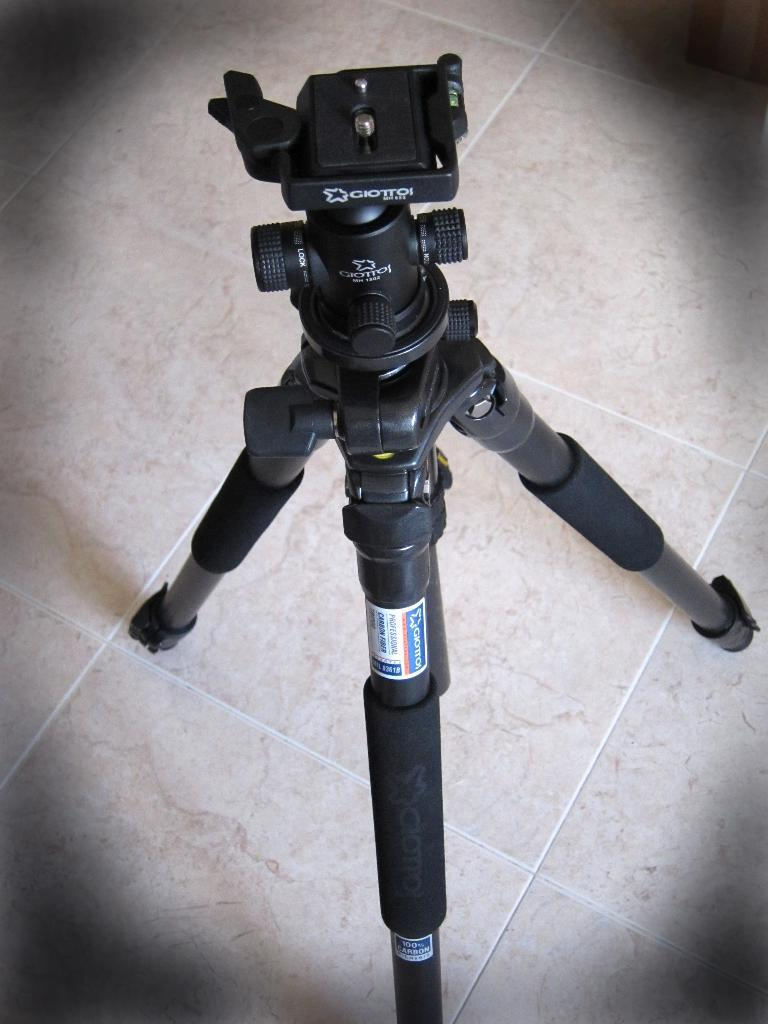What is the main object in the image? There is a camera tripod stand in the image. What type of surface is visible in the image? There is a floor visible in the image. What type of lunch is being prepared in the image? There is no lunch preparation visible in the image; it only features a camera tripod stand and a floor. 